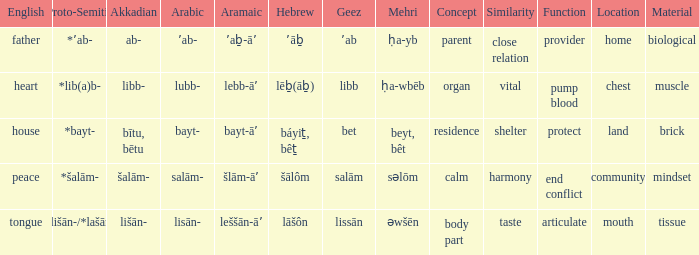If the aramaic is šlām-āʼ, what is the english equivalent? Peace. 